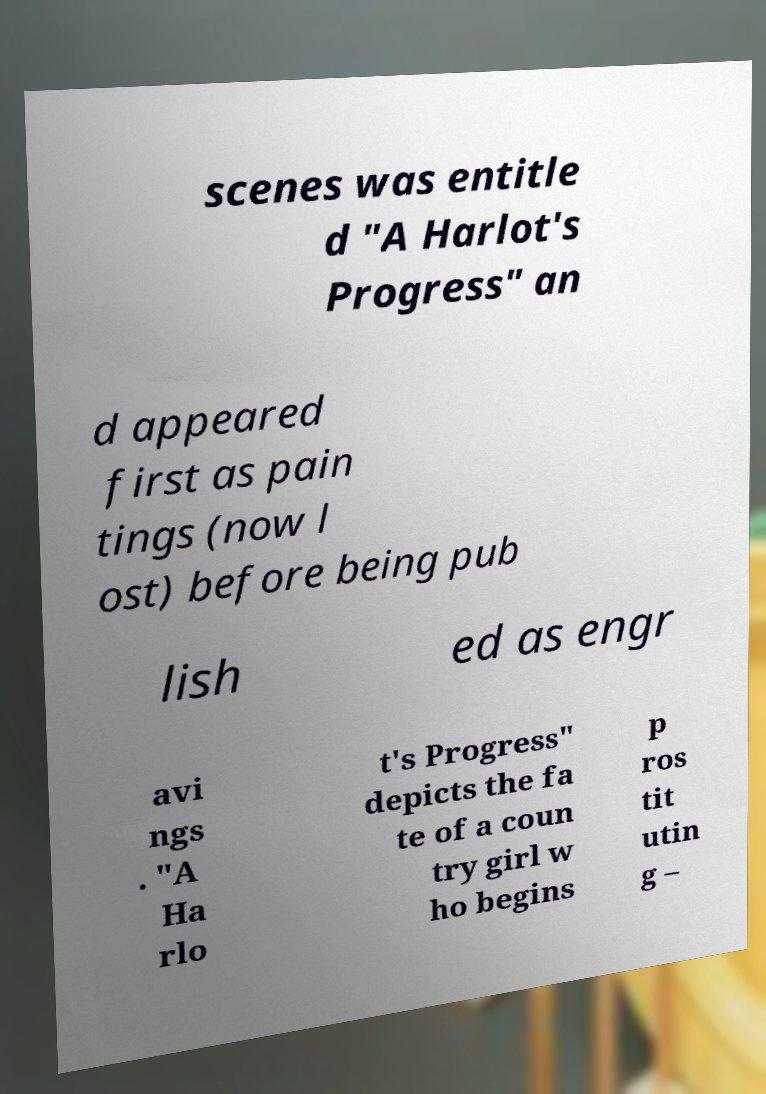What messages or text are displayed in this image? I need them in a readable, typed format. scenes was entitle d "A Harlot's Progress" an d appeared first as pain tings (now l ost) before being pub lish ed as engr avi ngs . "A Ha rlo t's Progress" depicts the fa te of a coun try girl w ho begins p ros tit utin g – 